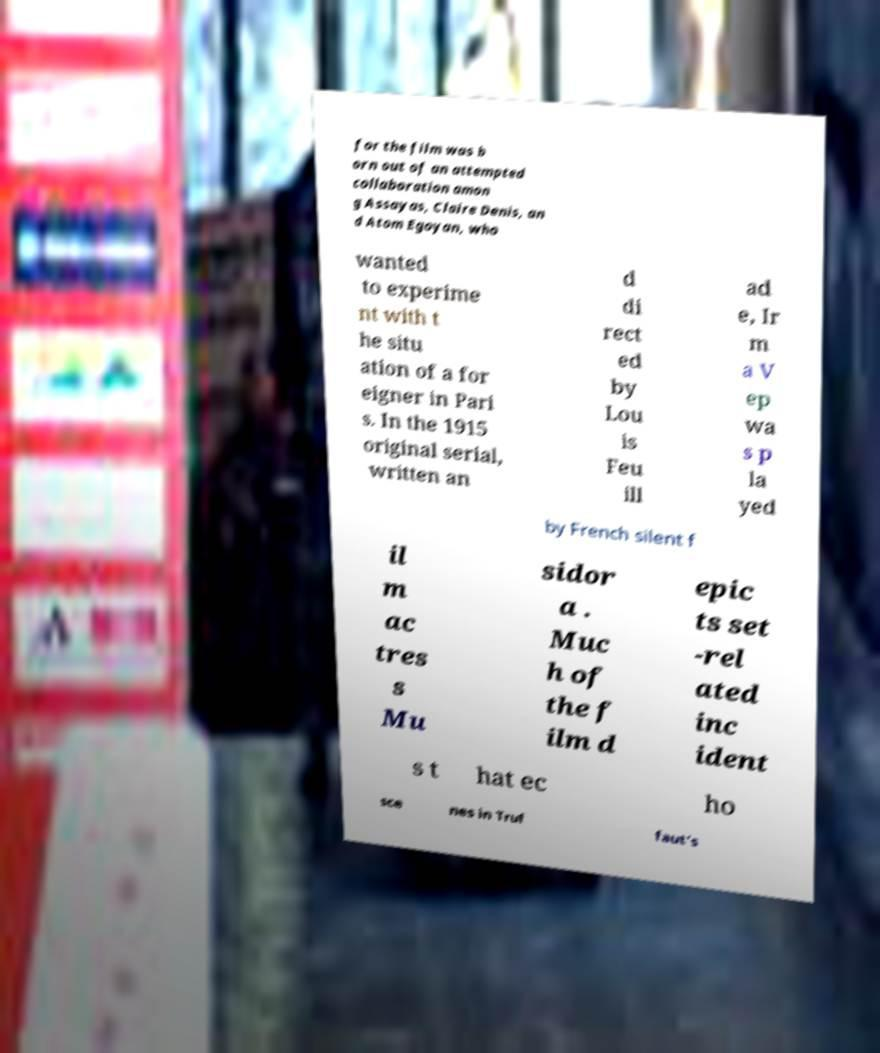Please read and relay the text visible in this image. What does it say? for the film was b orn out of an attempted collaboration amon g Assayas, Claire Denis, an d Atom Egoyan, who wanted to experime nt with t he situ ation of a for eigner in Pari s. In the 1915 original serial, written an d di rect ed by Lou is Feu ill ad e, Ir m a V ep wa s p la yed by French silent f il m ac tres s Mu sidor a . Muc h of the f ilm d epic ts set -rel ated inc ident s t hat ec ho sce nes in Truf faut's 